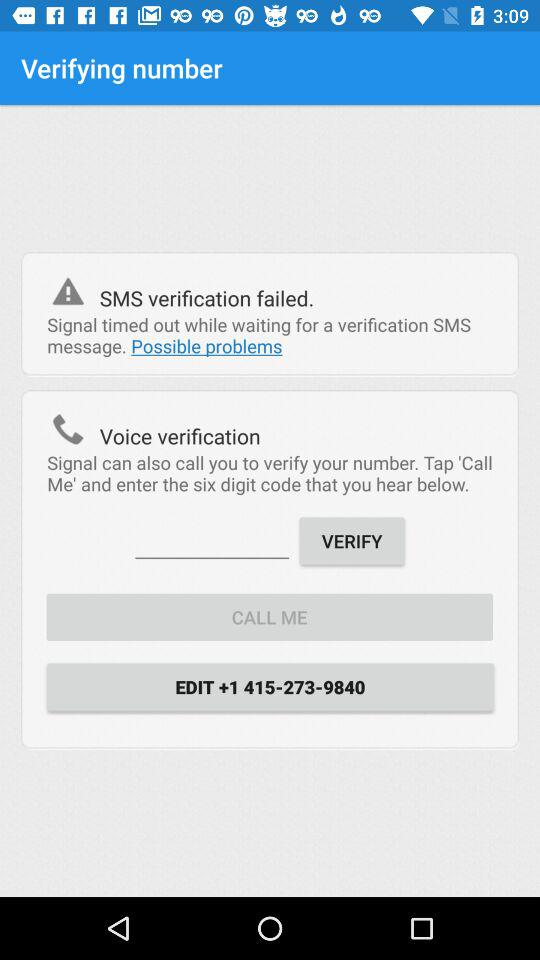How many actions can I take to verify my number?
Answer the question using a single word or phrase. 2 